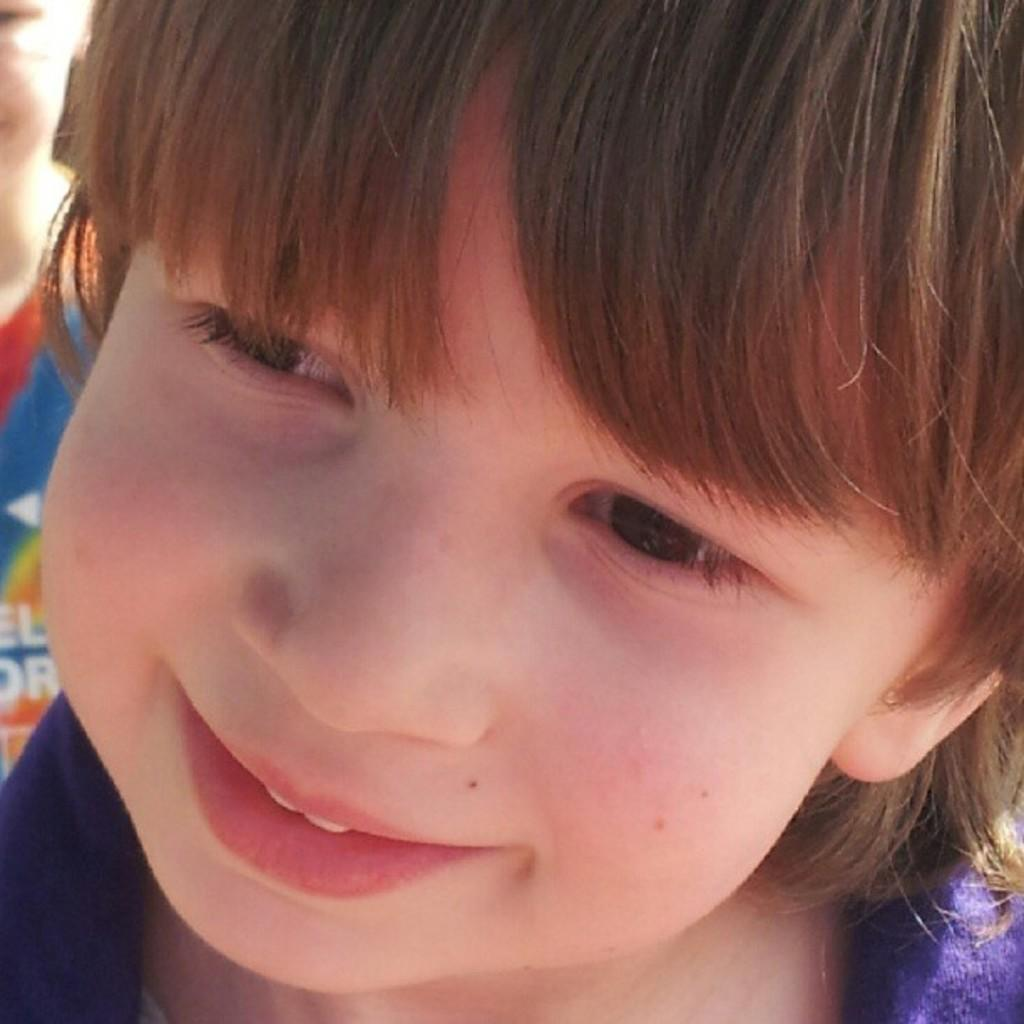What is the main subject of the image? The main subject of the image is the face of a kid. What expression does the kid have in the image? The kid is smiling in the image. What type of actor is performing in the image? There is no actor present in the image; it features the face of a kid. What type of pest can be seen crawling on the kid's face in the image? There are no pests visible on the kid's face in the image. 